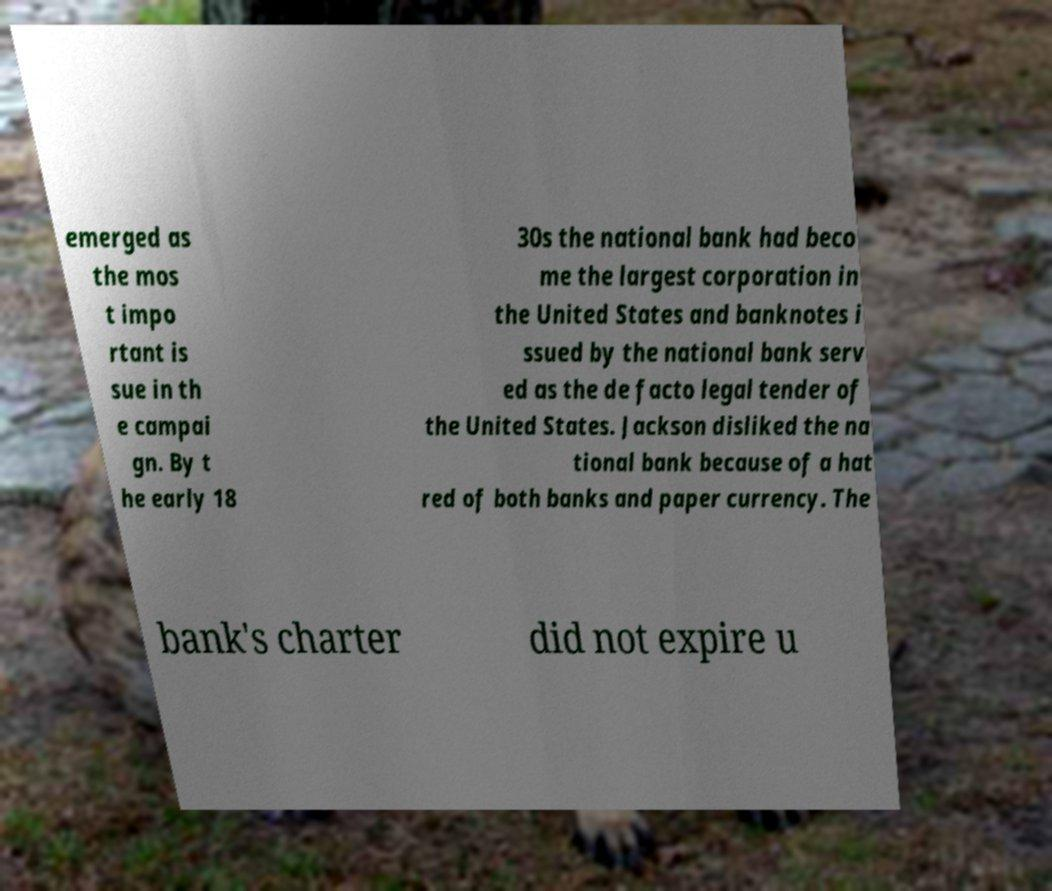Please identify and transcribe the text found in this image. emerged as the mos t impo rtant is sue in th e campai gn. By t he early 18 30s the national bank had beco me the largest corporation in the United States and banknotes i ssued by the national bank serv ed as the de facto legal tender of the United States. Jackson disliked the na tional bank because of a hat red of both banks and paper currency. The bank's charter did not expire u 